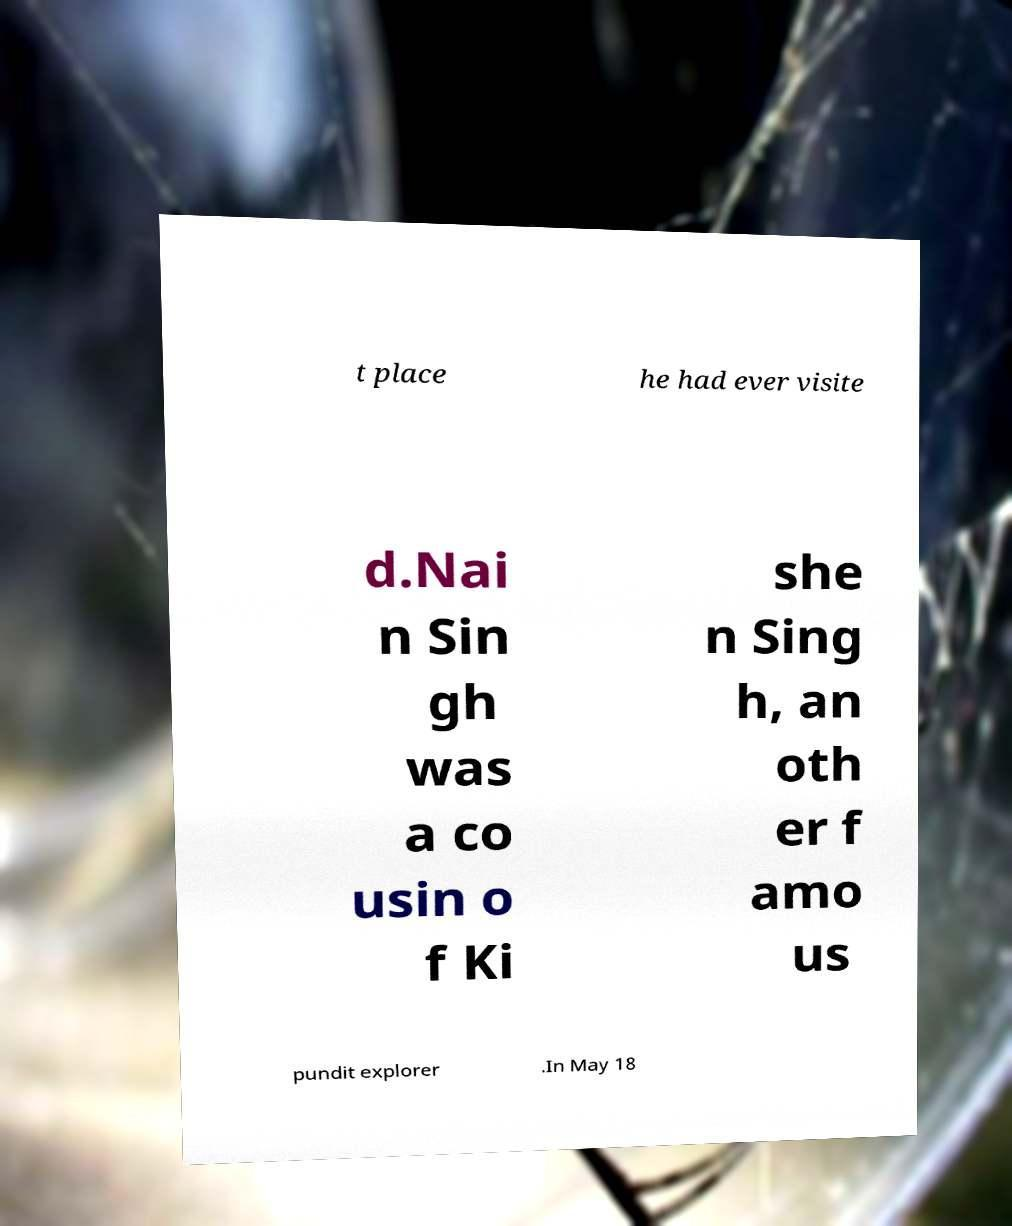For documentation purposes, I need the text within this image transcribed. Could you provide that? t place he had ever visite d.Nai n Sin gh was a co usin o f Ki she n Sing h, an oth er f amo us pundit explorer .In May 18 